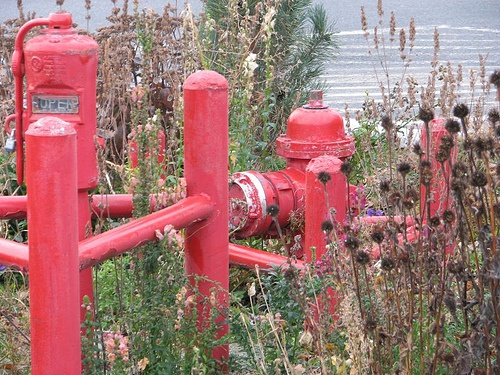Describe the objects in this image and their specific colors. I can see fire hydrant in darkgray, salmon, lightpink, and brown tones, fire hydrant in darkgray, salmon, brown, maroon, and lightpink tones, and fire hydrant in darkgray, salmon, lightpink, and brown tones in this image. 